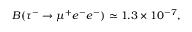Convert formula to latex. <formula><loc_0><loc_0><loc_500><loc_500>B ( \tau ^ { - } \to \mu ^ { + } e ^ { - } e ^ { - } ) \simeq 1 . 3 \times 1 0 ^ { - 7 } ,</formula> 